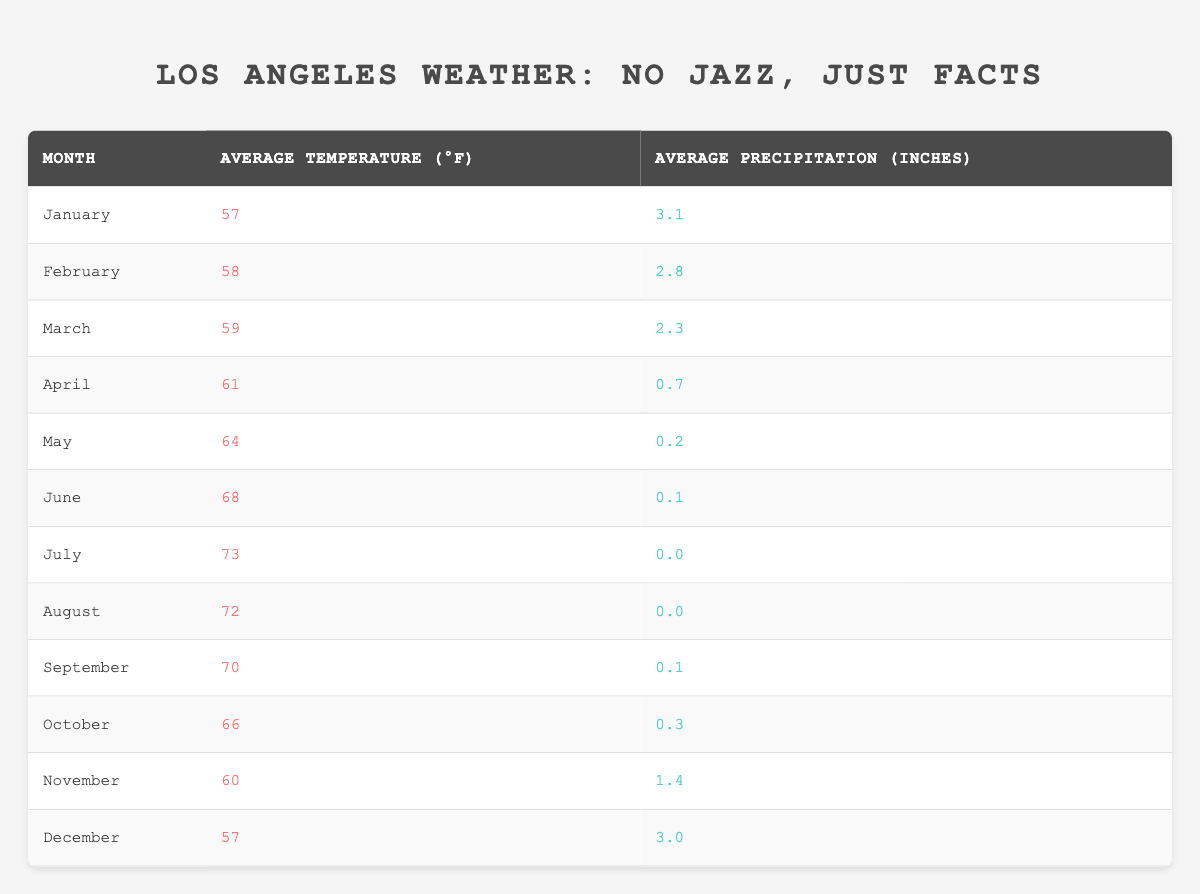What is the average temperature in July? The table shows that the average temperature in July is listed as 73°F. This data point can be directly retrieved from the table without any calculations needed.
Answer: 73°F Which month has the highest average precipitation? By examining the table, December has an average precipitation of 3.0 inches, which is higher than any other month listed. All other precipitation values are lower than this, confirming December as the month with the highest average.
Answer: December What is the total average precipitation for the summer months (June, July, August)? To find the total average precipitation for summer, we sum the average precipitation for June (0.1), July (0.0), and August (0.0): 0.1 + 0.0 + 0.0 = 0.1 inches. Therefore, the total average precipitation for these months is 0.1 inches.
Answer: 0.1 inches Is the average temperature in October higher than in March? The average temperature for October is 66°F and for March it is 59°F. Since 66°F is greater than 59°F, the statement is true. This comparison is made directly from the table's values.
Answer: Yes Which month has both the lowest average temperature and the lowest average precipitation? From the table, January has an average temperature of 57°F and an average precipitation of 3.1 inches, while February has a slightly higher temperature of 58°F but lower precipitation of 2.8 inches. As such, considering both criteria, we find that July has the lowest average precipitation (0.0 inches) but is not the lowest temperature, so it does not apply here. The comparison reveals no month qualifies for both low temperature and low precipitation simultaneously, as the lowest temperatures are associated with the highest precipitation levels.
Answer: No month meets both criteria What is the difference between the average temperatures in January and May? The average temperature in January is 57°F and in May it is 64°F. To find the difference, we subtract January's temperature from May's: 64 - 57 = 7°F. The difference indicates that May is warmer by 7°F compared to January.
Answer: 7°F 